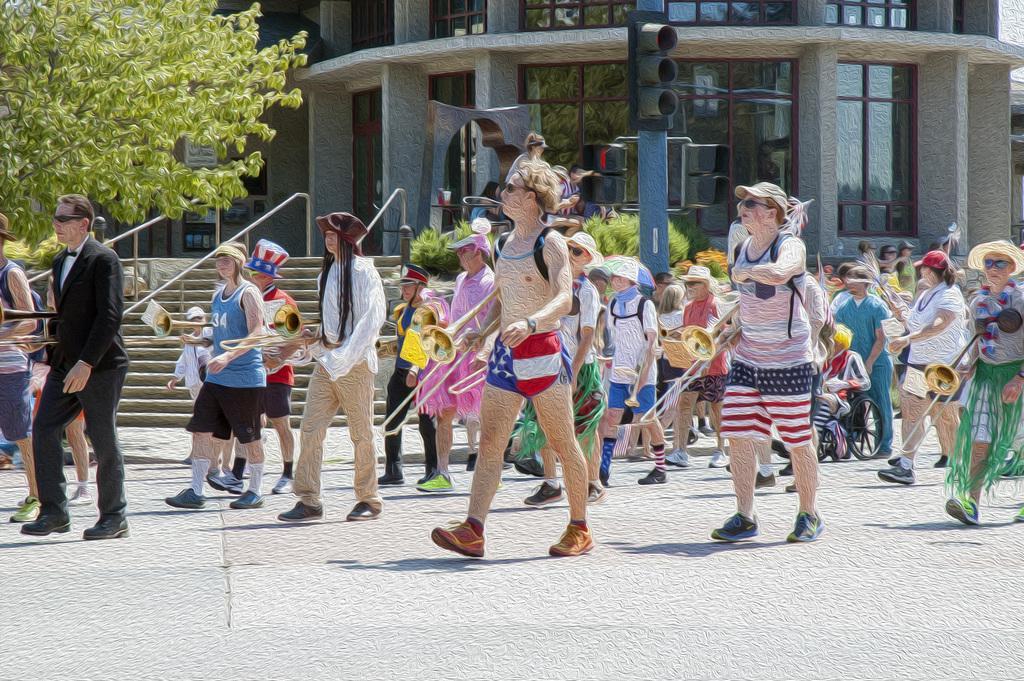In one or two sentences, can you explain what this image depicts? In the center of the image there are people walking on the road holding musical instruments. In the background of the image there is a building. There is a tree. There are staircases. There is a traffic signal. 